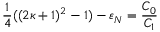Convert formula to latex. <formula><loc_0><loc_0><loc_500><loc_500>\frac { 1 } { 4 } ( ( 2 \kappa + 1 ) ^ { 2 } - 1 ) - \varepsilon _ { N } = \frac { C _ { 0 } } { C _ { 1 } }</formula> 